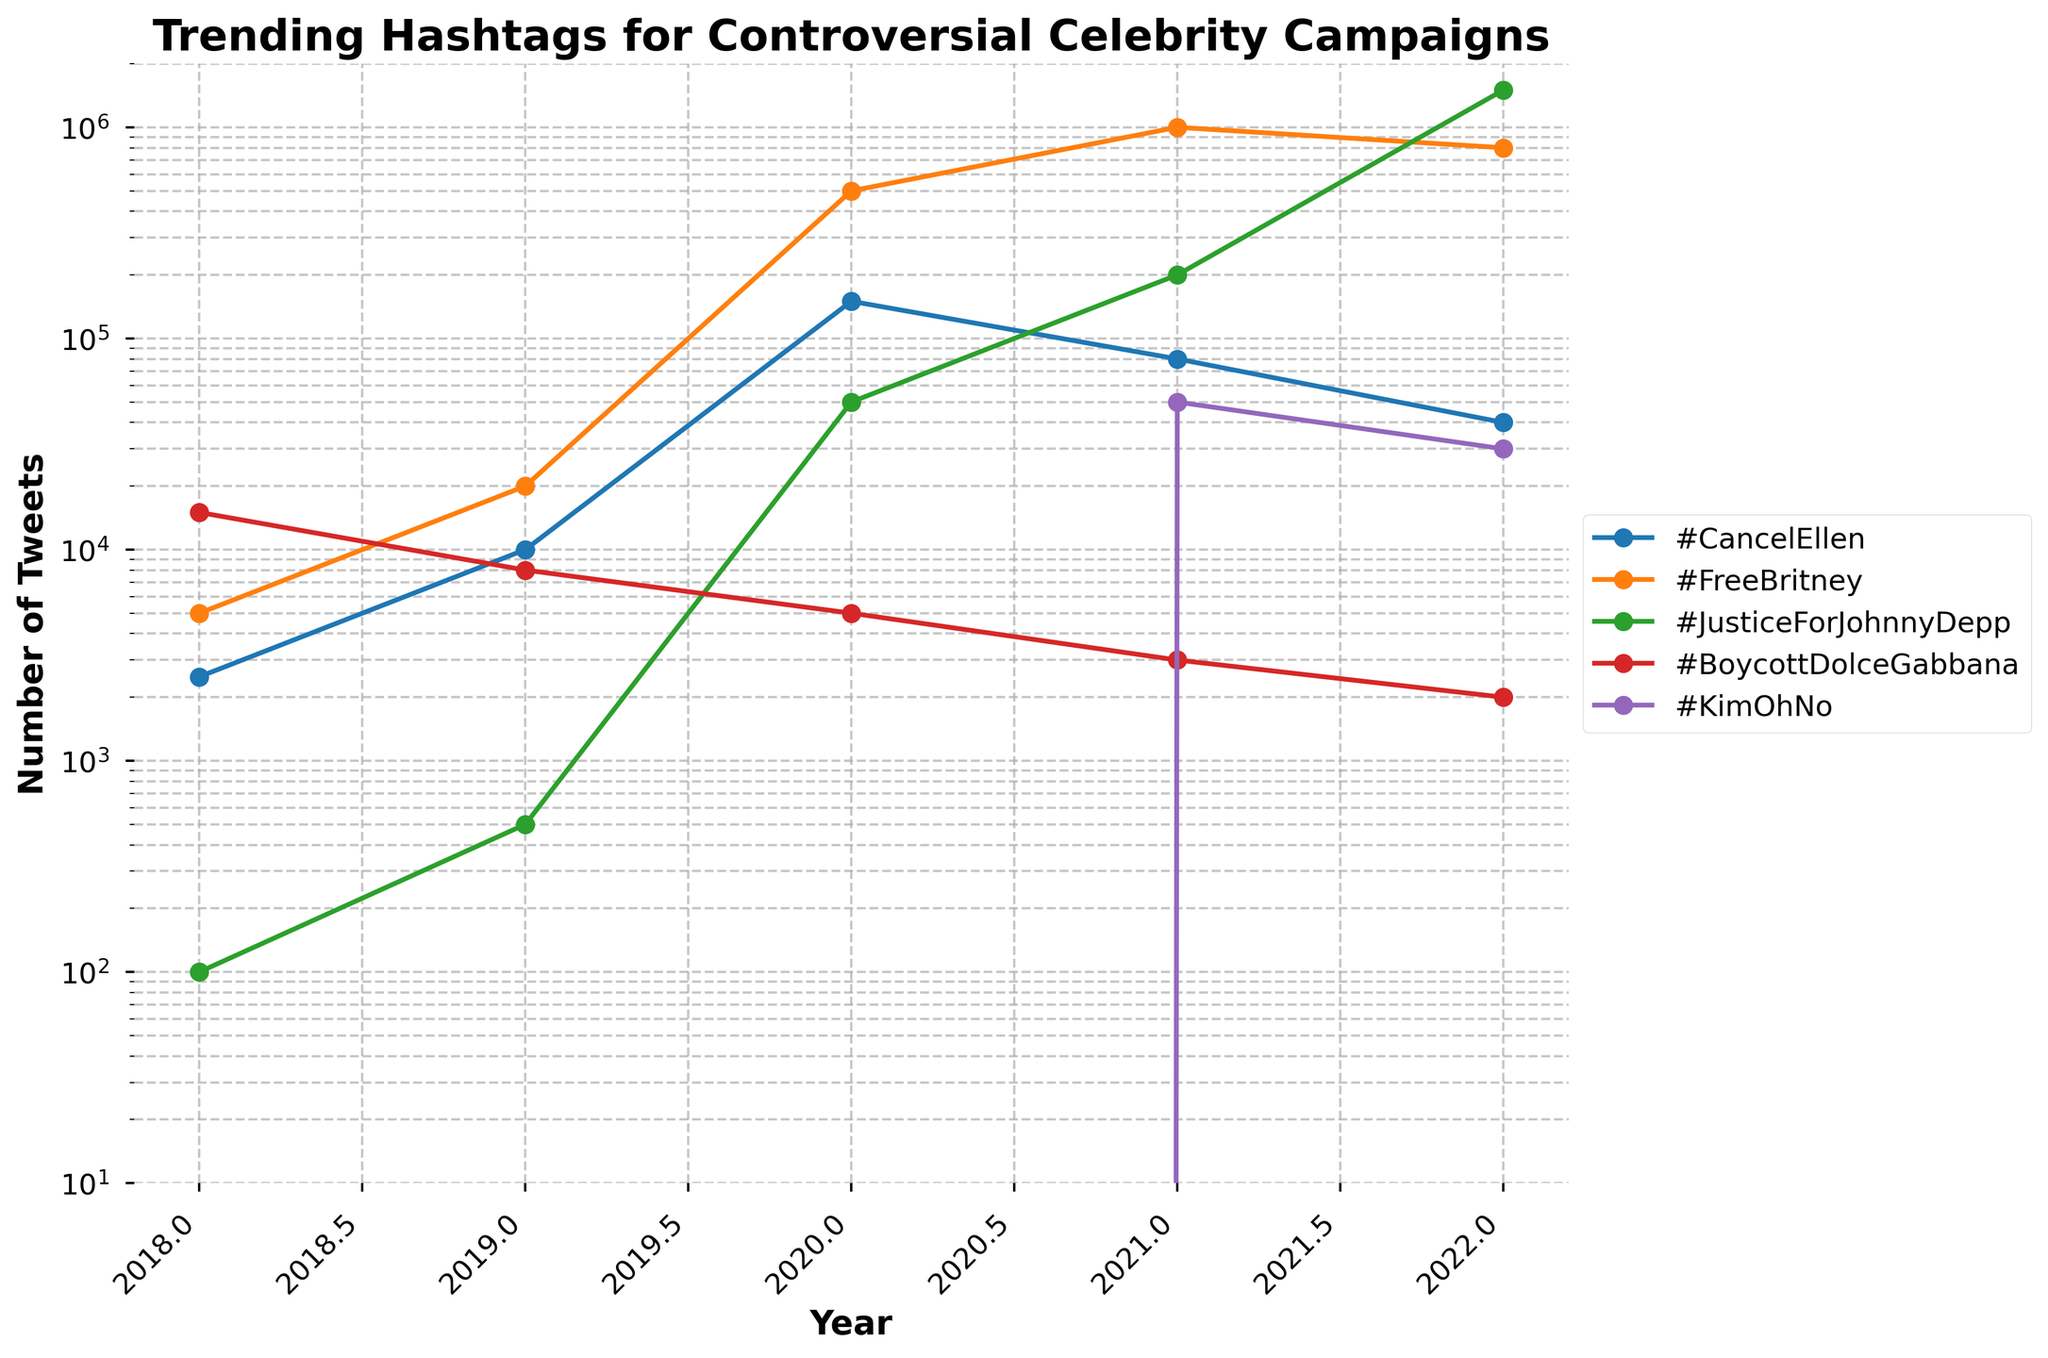What's the trend of the hashtag #CancelEllen from 2018 to 2022? To identify the trend, observe the line for #CancelEllen from left to right. From 2018 to 2020, there is a sharp rise, peaking in 2020. After 2020, the hashtag shows a decreasing trend through 2022.
Answer: Rising until 2020, then declining Which hashtag had the highest number of tweets in 2022? Compare the endpoints of all lines in 2022 to see which one is highest. #JusticeForJohnnyDepp has the highest number of tweets.
Answer: #JusticeForJohnnyDepp Between which consecutive years did #FreeBritney show the greatest increase? Look at the slope of the line representing #FreeBritney. The steepest slope occurs between 2019 and 2020.
Answer: 2019 to 2020 What is the total number of tweets for #BoycottDolceGabbana from 2018 to 2022? Sum the values for #BoycottDolceGabbana from each year: 15000 (2018) + 8000 (2019) + 5000 (2020) + 3000 (2021) + 2000 (2022) = 33000.
Answer: 33000 In which year did #KimOhNo first appear on the chart? Look for the first non-zero point on the line for #KimOhNo. It first appears in 2021.
Answer: 2021 Compare the trends of #CancelEllen and #FreeBritney between 2020 and 2022. Which one decreased more significantly? Look at the lines from 2020 to 2022 for both hashtags. #CancelEllen decreases from 150000 to 40000, while #FreeBritney decreases from 500000 to 800000. #CancelEllen shows a sharper decline.
Answer: #CancelEllen What is the difference in the number of tweets between #JusticeForJohnnyDepp in 2020 and 2022? Find the value of #JusticeForJohnnyDepp in 2020 (50000) and in 2022 (1500000), then subtract the earlier from the later: 1500000 - 50000 = 1450000.
Answer: 1450000 Which hashtag showed a consistent yearly increase from 2018 to 2022? Observe lines rising continuously without any drop from 2018 to 2022. Only #JusticeForJohnnyDepp consistently increases.
Answer: #JusticeForJohnnyDepp How many times greater were the tweets for #FreeBritney in 2022 compared to 2018? Divide the 2022 value by the 2018 value: 800000 / 5000 = 160.
Answer: 160 What visual indicator is used to depict the trend of each hashtag over time? Notice the graphical marks used along the lines, such as points connecting them and the overall progression of the line.
Answer: Lines with markers 